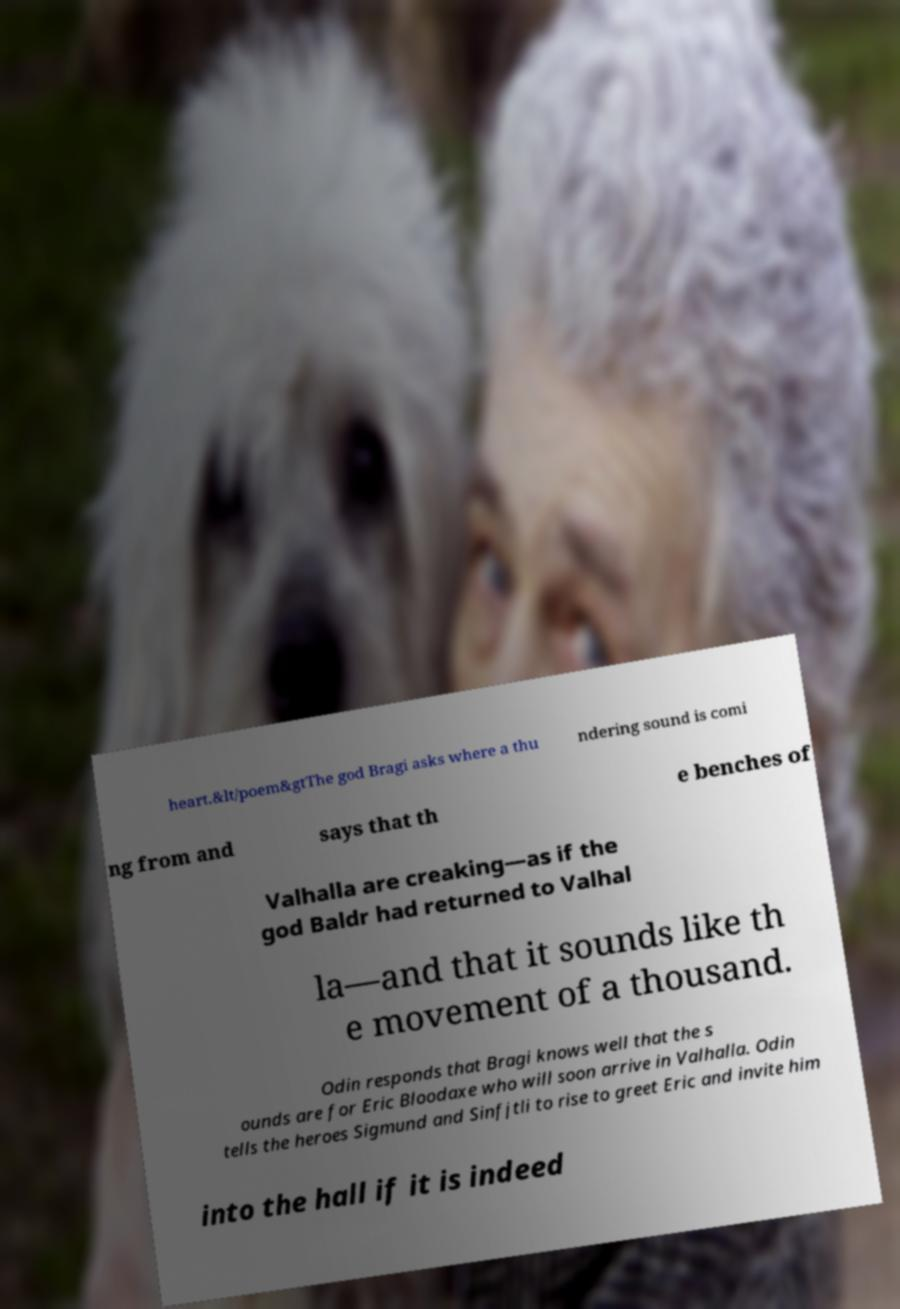Please read and relay the text visible in this image. What does it say? heart.&lt/poem&gtThe god Bragi asks where a thu ndering sound is comi ng from and says that th e benches of Valhalla are creaking—as if the god Baldr had returned to Valhal la—and that it sounds like th e movement of a thousand. Odin responds that Bragi knows well that the s ounds are for Eric Bloodaxe who will soon arrive in Valhalla. Odin tells the heroes Sigmund and Sinfjtli to rise to greet Eric and invite him into the hall if it is indeed 